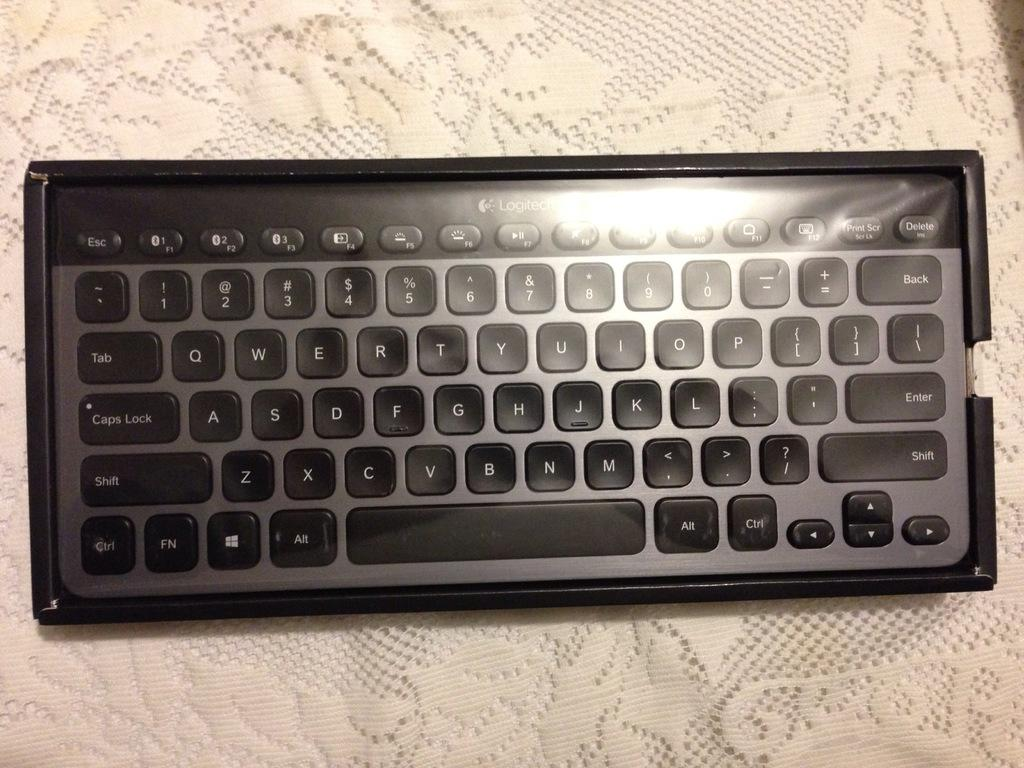What is the main object in the image? There is a keyboard in the image. What types of characters are present on the keyboard? The keyboard has alphabets, numbers, and other signs. What is the color of the surface on which the keyboard is placed? The keyboard is on a cream-colored surface. What type of skin condition can be seen on the keyboard in the image? There is no skin condition present on the keyboard in the image, as it is an inanimate object. 